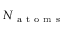<formula> <loc_0><loc_0><loc_500><loc_500>N _ { a t o m s }</formula> 